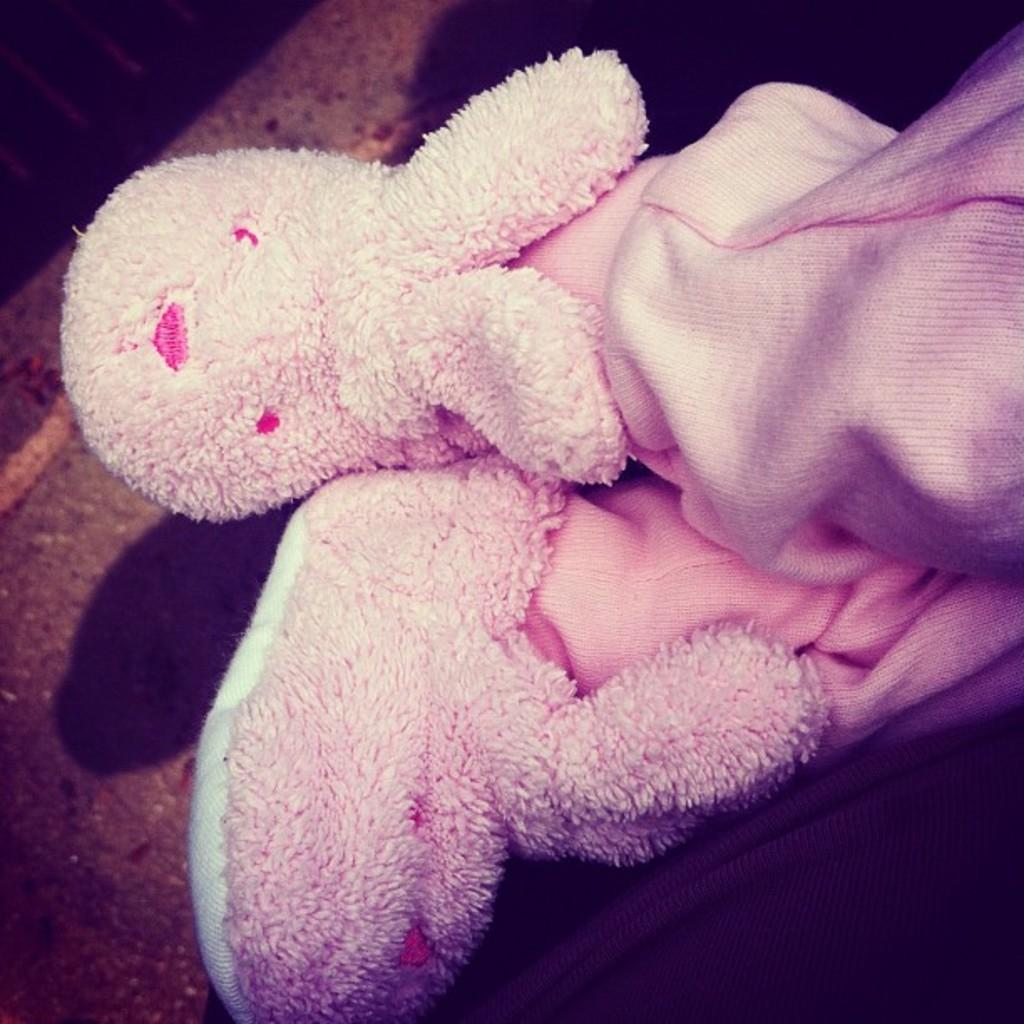What is present in the image? There is a person in the image. What is the person wearing on their feet? The person is wearing pink plush slippers. What else is the person wearing? The person is wearing pink pants. Where can the person be seen buying groceries in the image? There is no indication of a market or grocery shopping in the image. 